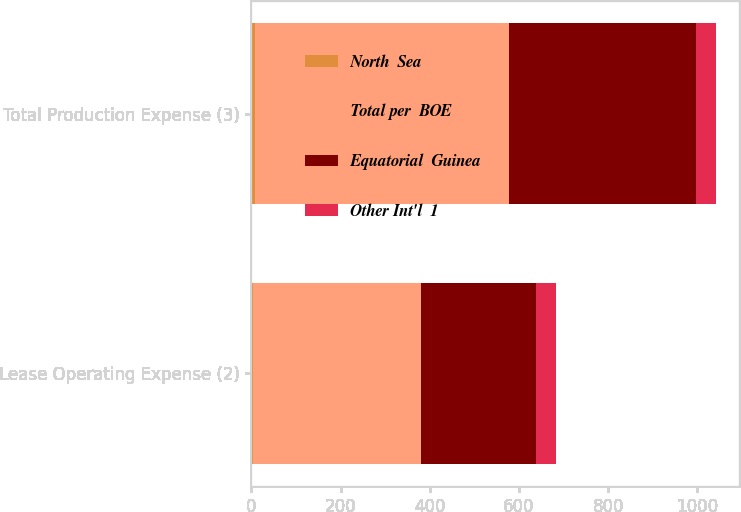Convert chart to OTSL. <chart><loc_0><loc_0><loc_500><loc_500><stacked_bar_chart><ecel><fcel>Lease Operating Expense (2)<fcel>Total Production Expense (3)<nl><fcel>North  Sea<fcel>4.93<fcel>7.48<nl><fcel>Total per  BOE<fcel>376<fcel>570<nl><fcel>Equatorial  Guinea<fcel>258<fcel>420<nl><fcel>Other Int'l  1<fcel>43<fcel>43<nl></chart> 